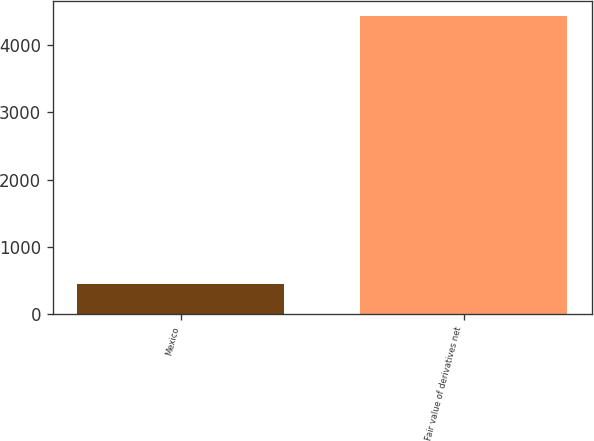Convert chart. <chart><loc_0><loc_0><loc_500><loc_500><bar_chart><fcel>Mexico<fcel>Fair value of derivatives net<nl><fcel>451<fcel>4432<nl></chart> 